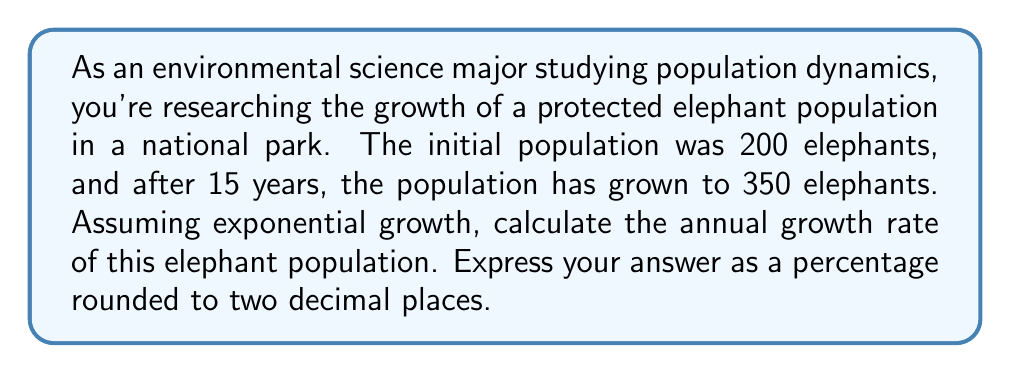Help me with this question. To solve this problem, we'll use the exponential growth formula:

$$A = P(1 + r)^t$$

Where:
$A$ = Final amount (population)
$P$ = Initial amount (population)
$r$ = Annual growth rate (in decimal form)
$t$ = Time period (in years)

Given:
$P = 200$ (initial population)
$A = 350$ (final population)
$t = 15$ years

Let's plug these values into the formula:

$$350 = 200(1 + r)^{15}$$

Now, we need to solve for $r$:

1) Divide both sides by 200:
   $$\frac{350}{200} = (1 + r)^{15}$$

2) Take the 15th root of both sides:
   $$\sqrt[15]{\frac{350}{200}} = 1 + r$$

3) Subtract 1 from both sides:
   $$\sqrt[15]{\frac{350}{200}} - 1 = r$$

4) Calculate the value:
   $$r \approx 0.0389$$

5) Convert to a percentage by multiplying by 100:
   $$r \approx 3.89\%$$

6) Round to two decimal places:
   $$r \approx 3.89\%$$
Answer: The annual growth rate of the elephant population is approximately 3.89%. 